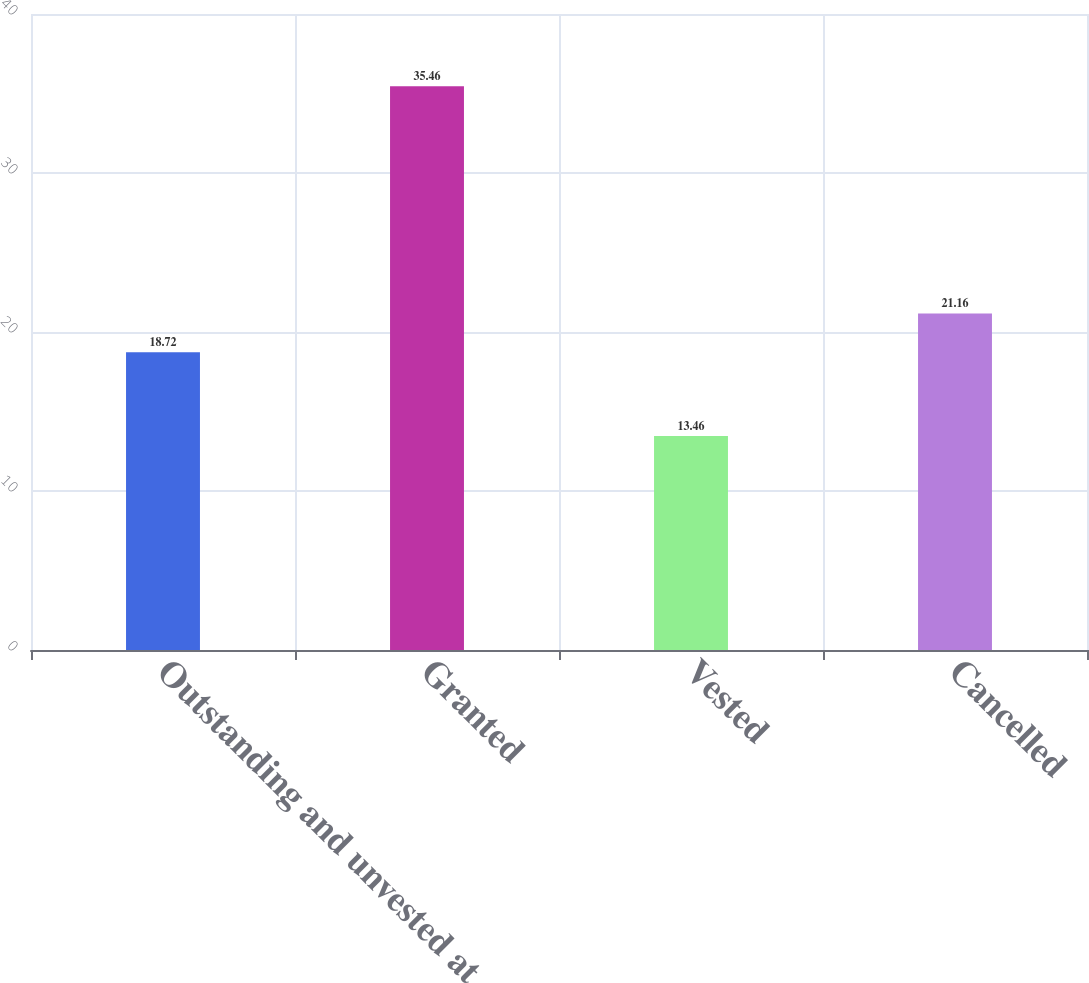<chart> <loc_0><loc_0><loc_500><loc_500><bar_chart><fcel>Outstanding and unvested at<fcel>Granted<fcel>Vested<fcel>Cancelled<nl><fcel>18.72<fcel>35.46<fcel>13.46<fcel>21.16<nl></chart> 